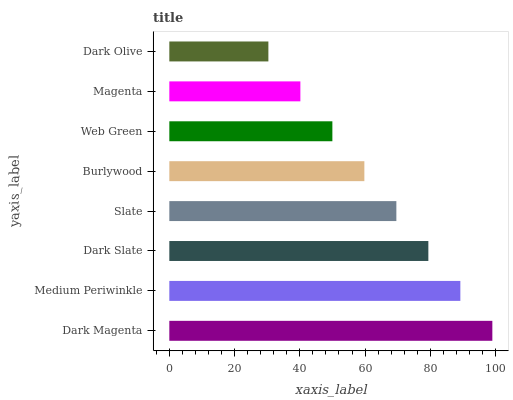Is Dark Olive the minimum?
Answer yes or no. Yes. Is Dark Magenta the maximum?
Answer yes or no. Yes. Is Medium Periwinkle the minimum?
Answer yes or no. No. Is Medium Periwinkle the maximum?
Answer yes or no. No. Is Dark Magenta greater than Medium Periwinkle?
Answer yes or no. Yes. Is Medium Periwinkle less than Dark Magenta?
Answer yes or no. Yes. Is Medium Periwinkle greater than Dark Magenta?
Answer yes or no. No. Is Dark Magenta less than Medium Periwinkle?
Answer yes or no. No. Is Slate the high median?
Answer yes or no. Yes. Is Burlywood the low median?
Answer yes or no. Yes. Is Web Green the high median?
Answer yes or no. No. Is Dark Olive the low median?
Answer yes or no. No. 